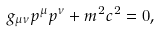Convert formula to latex. <formula><loc_0><loc_0><loc_500><loc_500>g _ { \mu \nu } p ^ { \mu } p ^ { \nu } + m ^ { 2 } c ^ { 2 } = 0 ,</formula> 